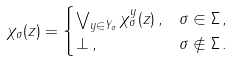Convert formula to latex. <formula><loc_0><loc_0><loc_500><loc_500>\chi _ { \sigma } ( z ) & = \begin{cases} \bigvee _ { y \in Y _ { \sigma } } \chi _ { \sigma } ^ { y } ( z ) \, , & \sigma \in \Sigma \, , \\ \bot \, , & \sigma \not \in \Sigma \, . \end{cases}</formula> 